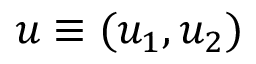Convert formula to latex. <formula><loc_0><loc_0><loc_500><loc_500>u \equiv ( u _ { 1 } , u _ { 2 } )</formula> 